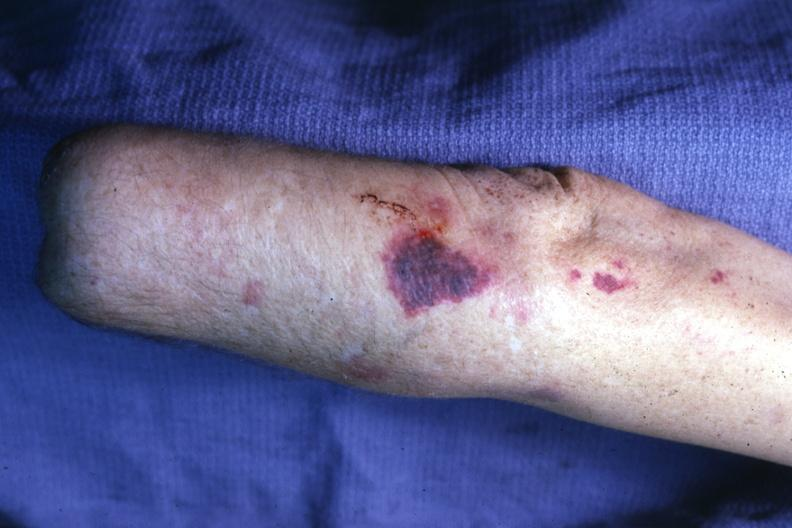where is this?
Answer the question using a single word or phrase. Skin 